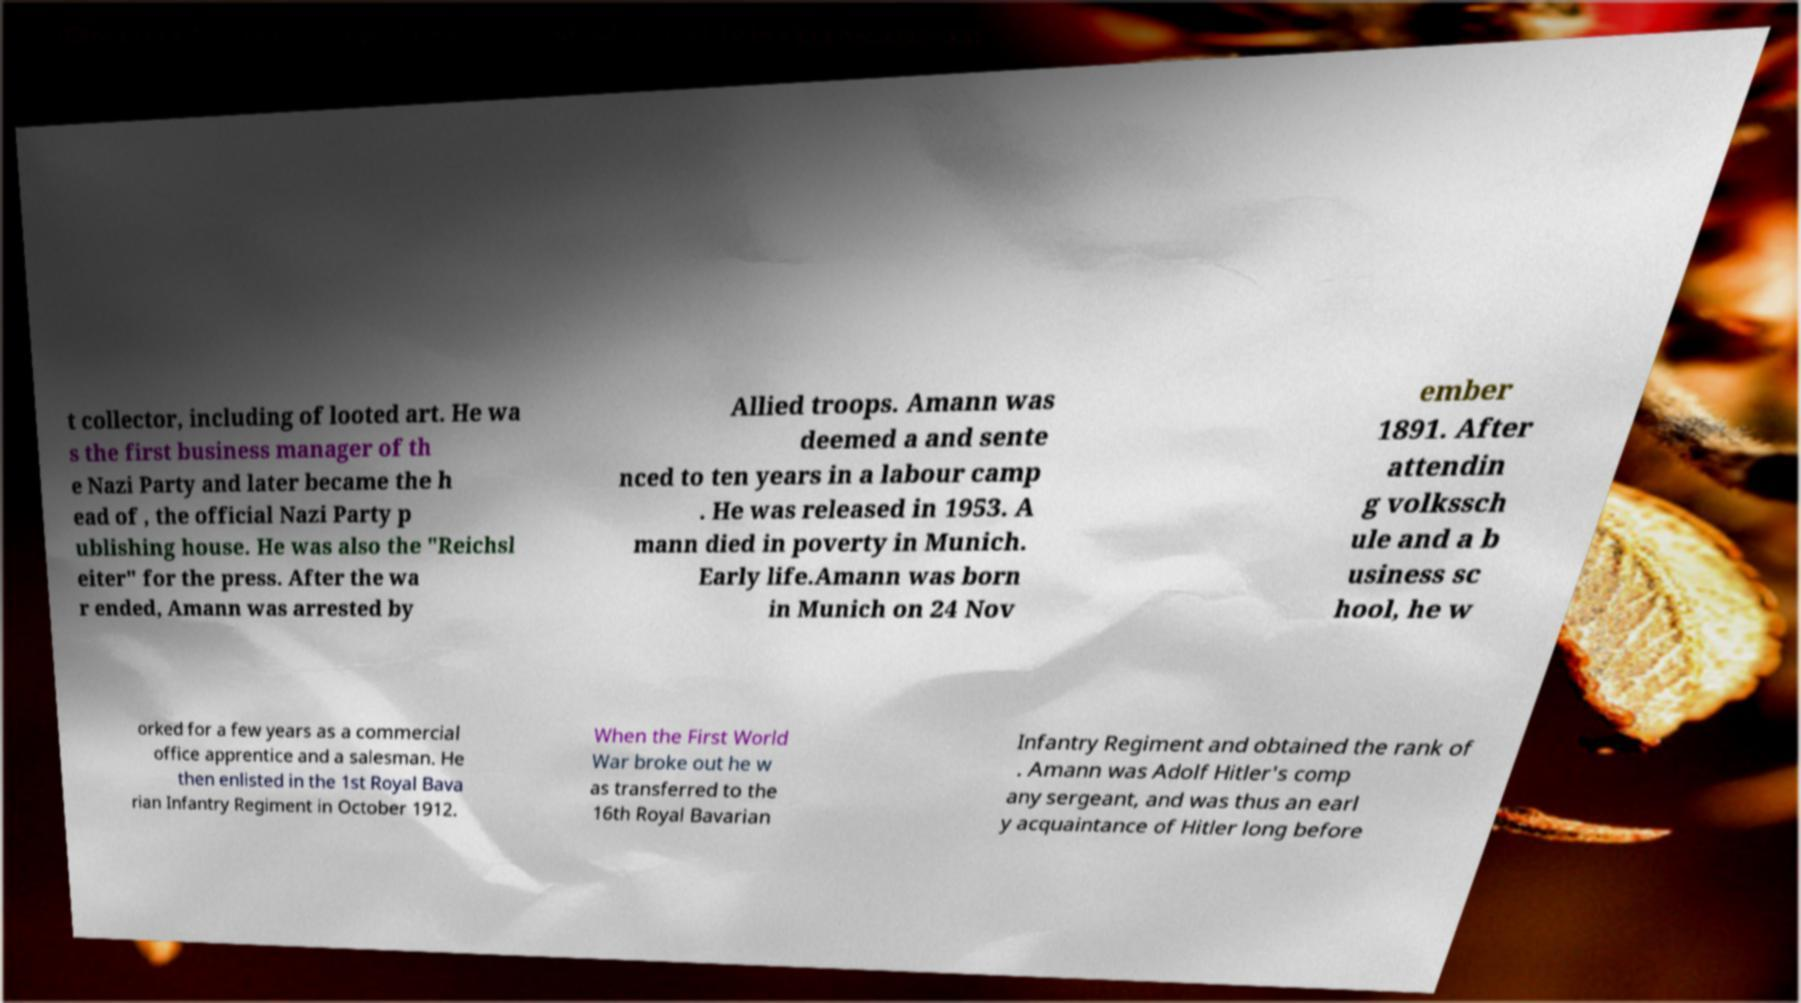Can you read and provide the text displayed in the image?This photo seems to have some interesting text. Can you extract and type it out for me? t collector, including of looted art. He wa s the first business manager of th e Nazi Party and later became the h ead of , the official Nazi Party p ublishing house. He was also the "Reichsl eiter" for the press. After the wa r ended, Amann was arrested by Allied troops. Amann was deemed a and sente nced to ten years in a labour camp . He was released in 1953. A mann died in poverty in Munich. Early life.Amann was born in Munich on 24 Nov ember 1891. After attendin g volkssch ule and a b usiness sc hool, he w orked for a few years as a commercial office apprentice and a salesman. He then enlisted in the 1st Royal Bava rian Infantry Regiment in October 1912. When the First World War broke out he w as transferred to the 16th Royal Bavarian Infantry Regiment and obtained the rank of . Amann was Adolf Hitler's comp any sergeant, and was thus an earl y acquaintance of Hitler long before 